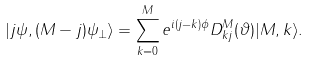Convert formula to latex. <formula><loc_0><loc_0><loc_500><loc_500>| j \psi , ( M - j ) \psi _ { \perp } \rangle = \sum _ { k = 0 } ^ { M } e ^ { i ( j - k ) \phi } D _ { k j } ^ { M } ( \vartheta ) | M , k \rangle .</formula> 